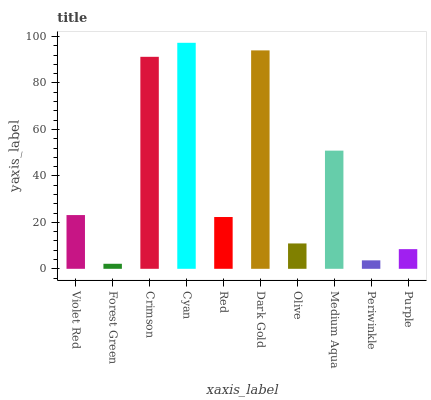Is Forest Green the minimum?
Answer yes or no. Yes. Is Cyan the maximum?
Answer yes or no. Yes. Is Crimson the minimum?
Answer yes or no. No. Is Crimson the maximum?
Answer yes or no. No. Is Crimson greater than Forest Green?
Answer yes or no. Yes. Is Forest Green less than Crimson?
Answer yes or no. Yes. Is Forest Green greater than Crimson?
Answer yes or no. No. Is Crimson less than Forest Green?
Answer yes or no. No. Is Violet Red the high median?
Answer yes or no. Yes. Is Red the low median?
Answer yes or no. Yes. Is Dark Gold the high median?
Answer yes or no. No. Is Purple the low median?
Answer yes or no. No. 